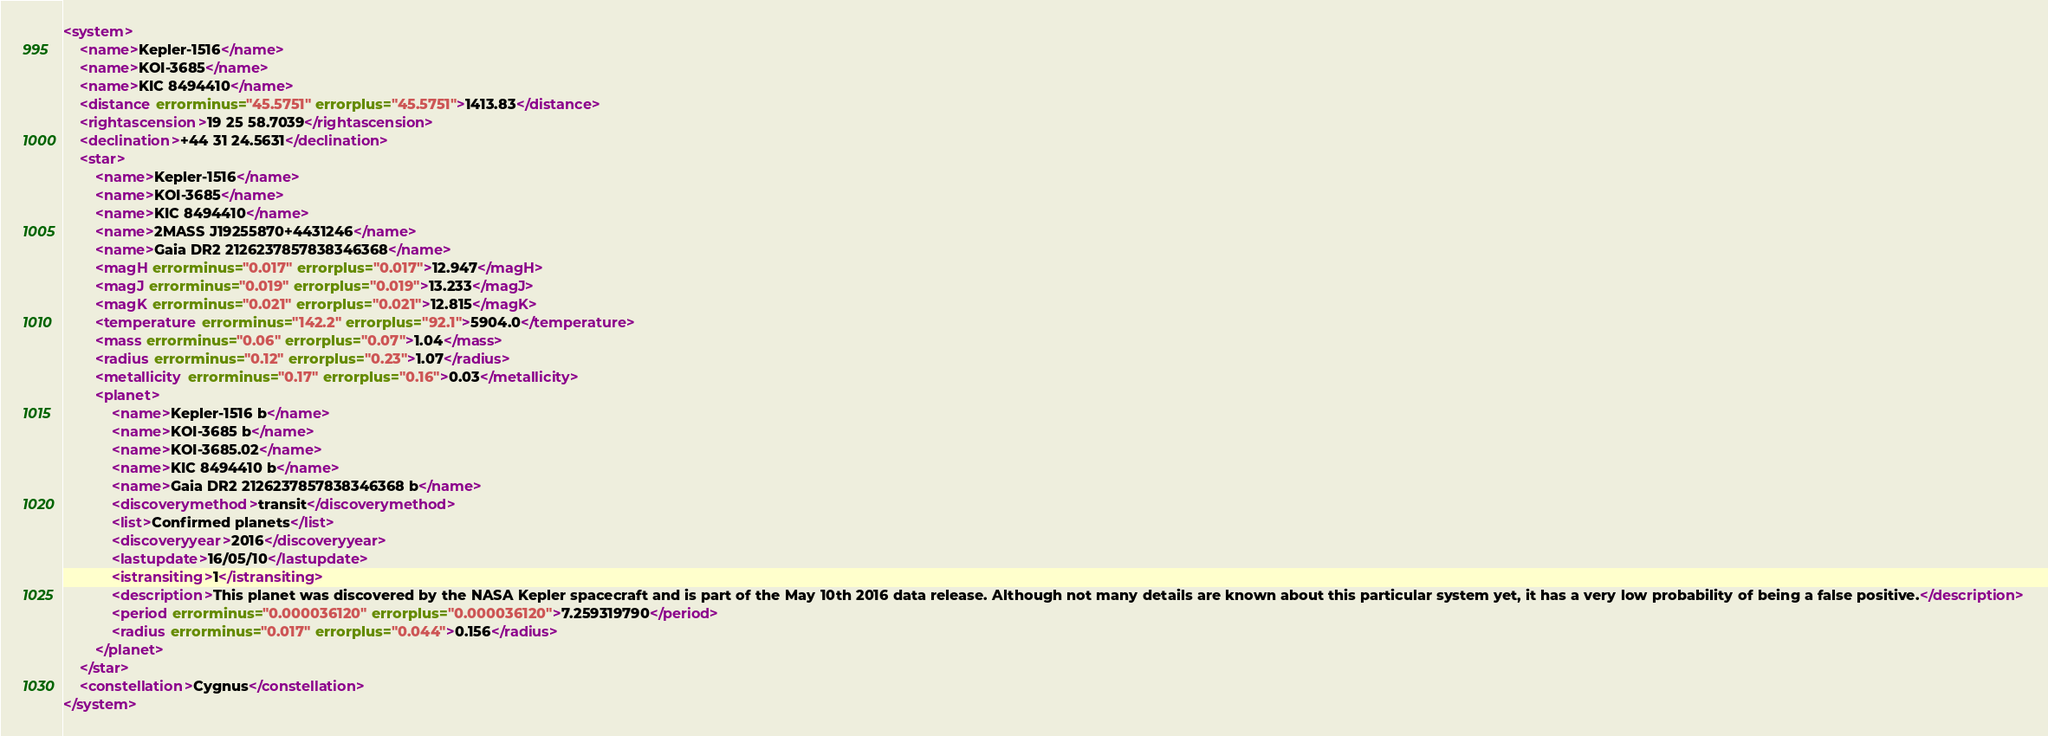Convert code to text. <code><loc_0><loc_0><loc_500><loc_500><_XML_><system>
	<name>Kepler-1516</name>
	<name>KOI-3685</name>
	<name>KIC 8494410</name>
	<distance errorminus="45.5751" errorplus="45.5751">1413.83</distance>
	<rightascension>19 25 58.7039</rightascension>
	<declination>+44 31 24.5631</declination>
	<star>
		<name>Kepler-1516</name>
		<name>KOI-3685</name>
		<name>KIC 8494410</name>
		<name>2MASS J19255870+4431246</name>
		<name>Gaia DR2 2126237857838346368</name>
		<magH errorminus="0.017" errorplus="0.017">12.947</magH>
		<magJ errorminus="0.019" errorplus="0.019">13.233</magJ>
		<magK errorminus="0.021" errorplus="0.021">12.815</magK>
		<temperature errorminus="142.2" errorplus="92.1">5904.0</temperature>
		<mass errorminus="0.06" errorplus="0.07">1.04</mass>
		<radius errorminus="0.12" errorplus="0.23">1.07</radius>
		<metallicity errorminus="0.17" errorplus="0.16">0.03</metallicity>
		<planet>
			<name>Kepler-1516 b</name>
			<name>KOI-3685 b</name>
			<name>KOI-3685.02</name>
			<name>KIC 8494410 b</name>
			<name>Gaia DR2 2126237857838346368 b</name>
			<discoverymethod>transit</discoverymethod>
			<list>Confirmed planets</list>
			<discoveryyear>2016</discoveryyear>
			<lastupdate>16/05/10</lastupdate>
			<istransiting>1</istransiting>
			<description>This planet was discovered by the NASA Kepler spacecraft and is part of the May 10th 2016 data release. Although not many details are known about this particular system yet, it has a very low probability of being a false positive.</description>
			<period errorminus="0.000036120" errorplus="0.000036120">7.259319790</period>
			<radius errorminus="0.017" errorplus="0.044">0.156</radius>
		</planet>
	</star>
	<constellation>Cygnus</constellation>
</system>
</code> 